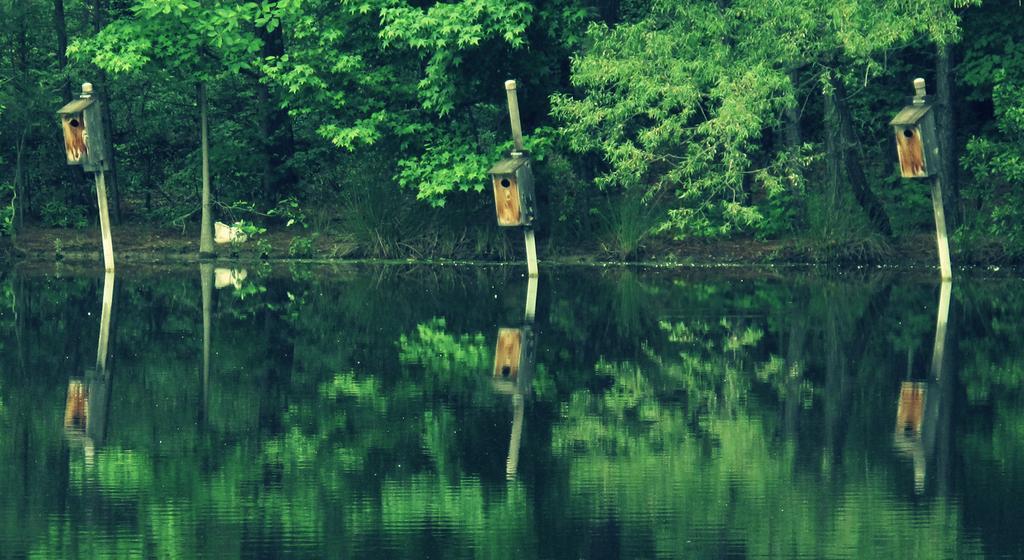Can you describe this image briefly? In this image at the bottom there is a river, and in the background there are some trees poles and some boxes. 